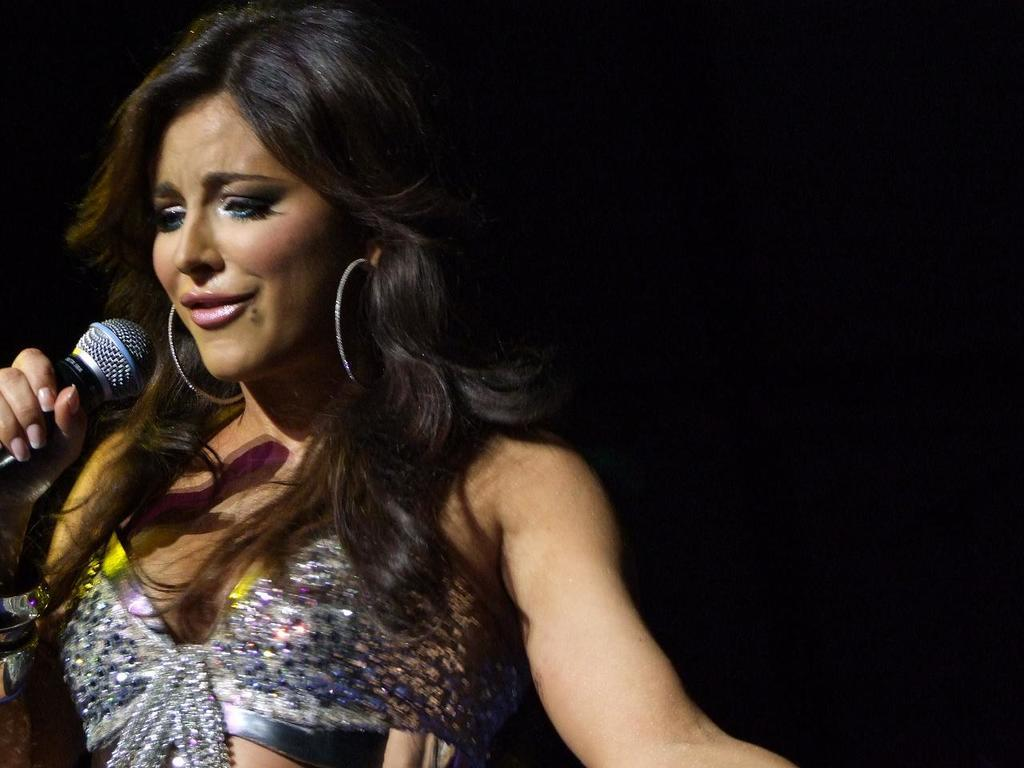What is the main subject of the image? The main subject of the image is a woman. What is the woman holding in the image? The woman is holding a mic in the image. What expression does the woman have in the image? The woman is smiling in the image. What type of recess can be seen in the image? There is no recess present in the image; it features a woman holding a mic and smiling. What town is depicted in the image? The image does not depict a town; it focuses on the woman holding a mic and smiling. 